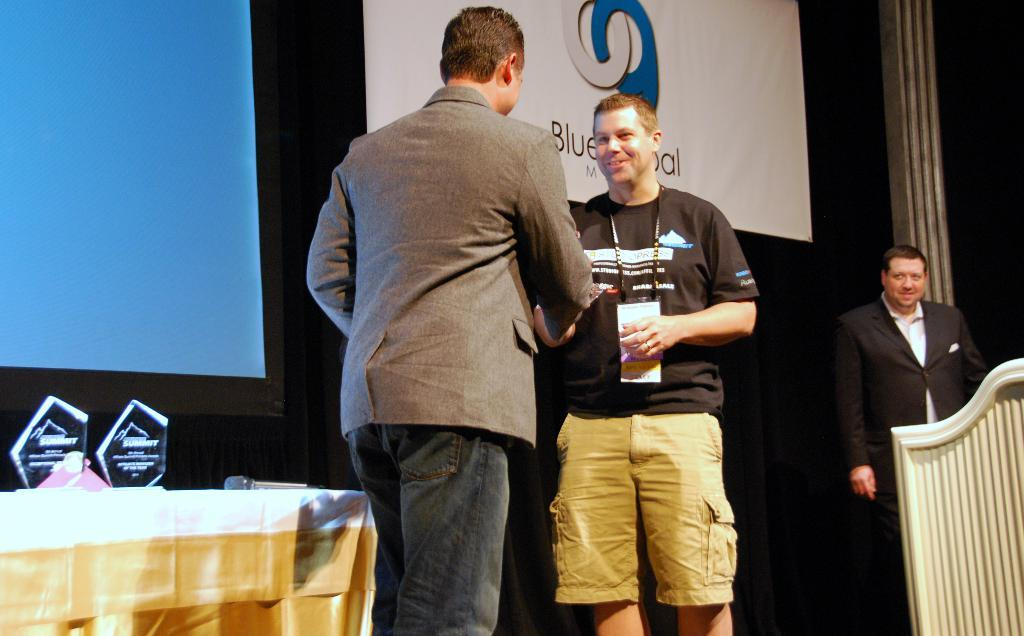Where was the image taken? The image was taken on a stage. How many people are standing on the stage? There are three persons standing on the stage. What is located behind the people on the stage? There is a table, a microphone, and a banner behind the people on the stage. What type of dress is the moon wearing in the image? There is no moon present in the image, and therefore no dress can be observed. What type of crime is being committed on the stage in the image? There is no indication of a crime being committed in the image. 